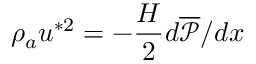Convert formula to latex. <formula><loc_0><loc_0><loc_500><loc_500>\rho _ { a } u ^ { * 2 } = - \frac { H } { 2 } d \overline { { \mathcal { P } } } / d x</formula> 